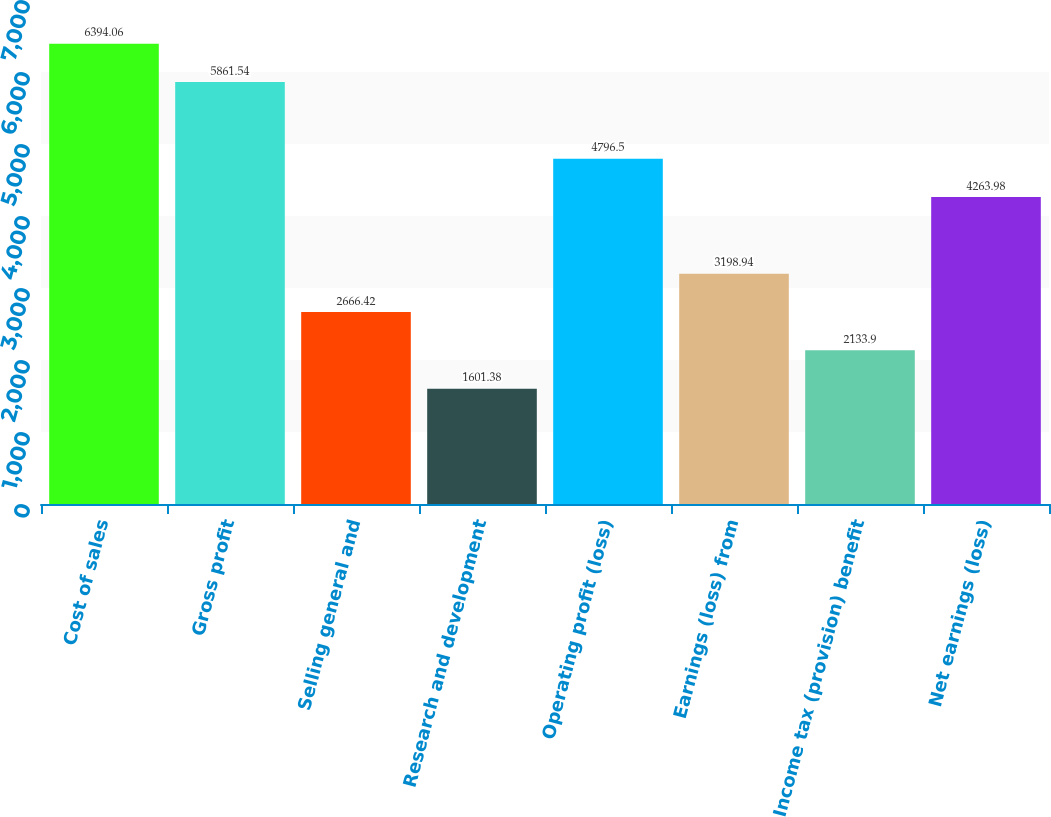Convert chart to OTSL. <chart><loc_0><loc_0><loc_500><loc_500><bar_chart><fcel>Cost of sales<fcel>Gross profit<fcel>Selling general and<fcel>Research and development<fcel>Operating profit (loss)<fcel>Earnings (loss) from<fcel>Income tax (provision) benefit<fcel>Net earnings (loss)<nl><fcel>6394.06<fcel>5861.54<fcel>2666.42<fcel>1601.38<fcel>4796.5<fcel>3198.94<fcel>2133.9<fcel>4263.98<nl></chart> 